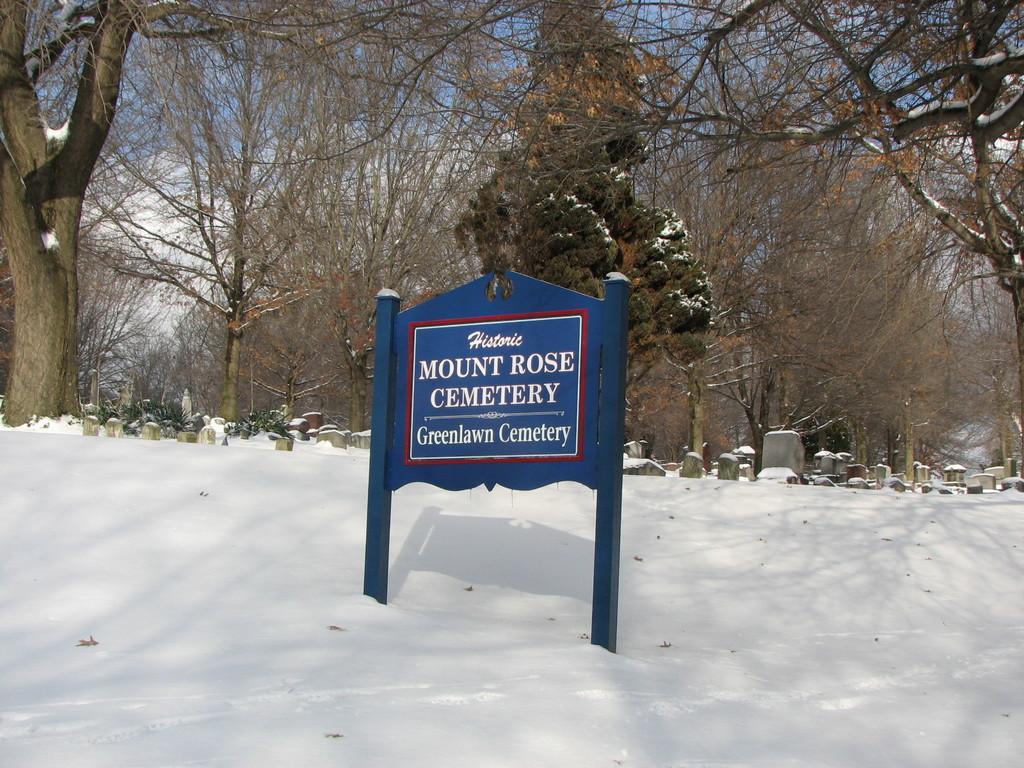Please provide a concise description of this image. In this image there is a snow land and board on that board there is a some text, in the background there are trees and stones. 